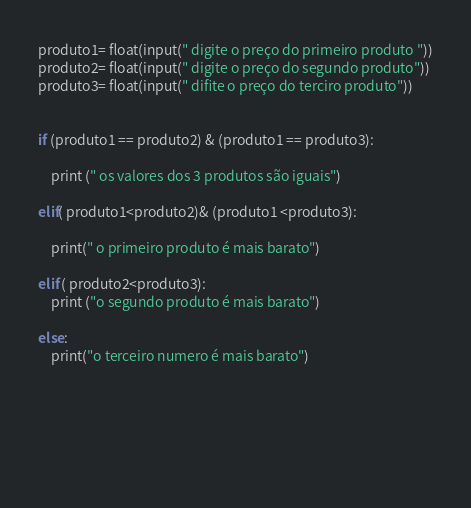Convert code to text. <code><loc_0><loc_0><loc_500><loc_500><_Python_>produto1= float(input(" digite o preço do primeiro produto "))
produto2= float(input(" digite o preço do segundo produto"))
produto3= float(input(" difite o preço do terciro produto"))

                
if (produto1 == produto2) & (produto1 == produto3):

    print (" os valores dos 3 produtos são iguais")

elif( produto1<produto2)& (produto1 <produto3):
    
    print(" o primeiro produto é mais barato")

elif ( produto2<produto3):
    print ("o segundo produto é mais barato")

else:
    print("o terceiro numero é mais barato")



                
                
                
</code> 